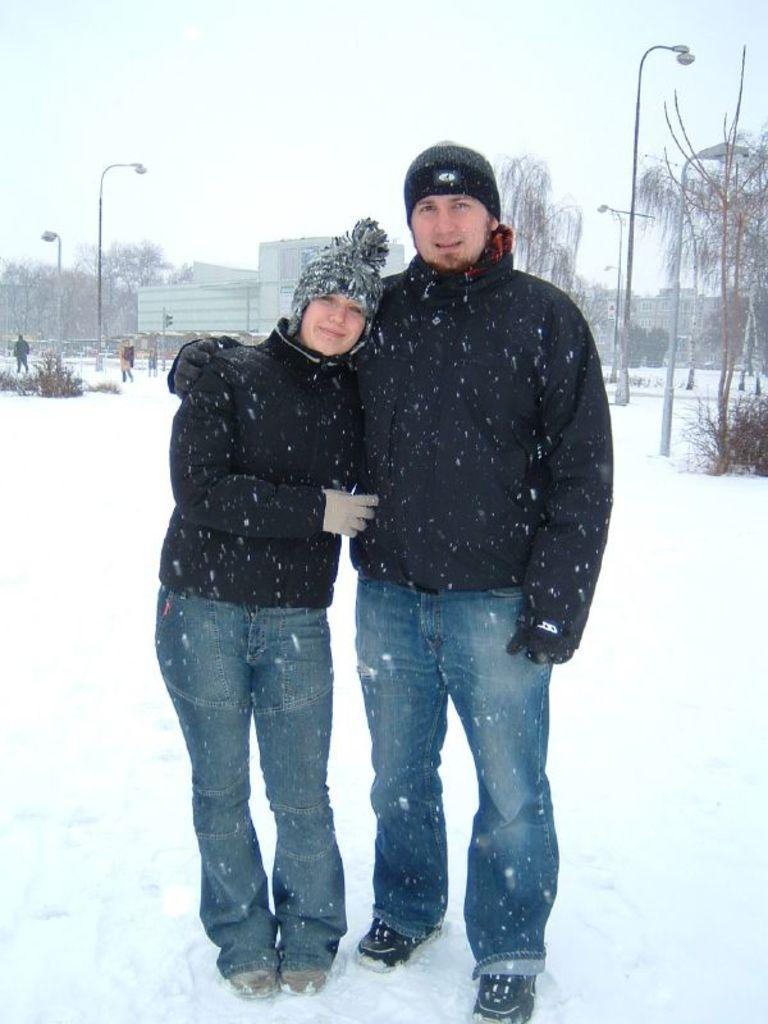How many people are present in the image? There are two people in the image, a man and a woman. What is the surface they are standing on? Both the man and woman are standing on the snow. What can be seen in the background of the image? There are street poles, street lights, buildings, trees, and the sky visible in the background of the image. What type of ear is visible on the woman in the image? There is no ear visible on the woman in the image; only her face and body are visible. What is the relationship between the man and woman in the image? The provided facts do not give any information about the relationship between the man and woman in the image. 